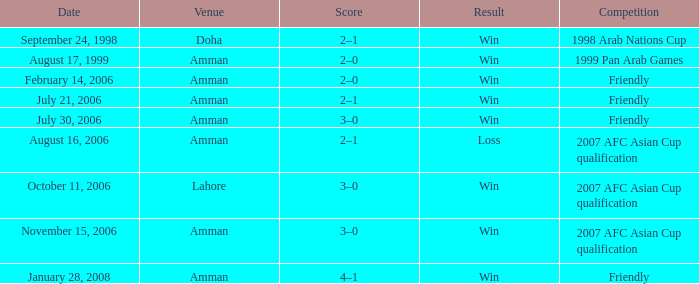What was the score of the friendly match at Amman on February 14, 2006? 2–0. 